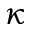<formula> <loc_0><loc_0><loc_500><loc_500>\kappa</formula> 